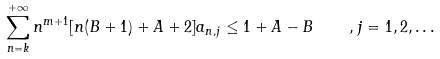<formula> <loc_0><loc_0><loc_500><loc_500>\sum ^ { + \infty } _ { n = k } n ^ { m + 1 } [ n ( B + 1 ) + A + 2 ] a _ { n , j } \leq 1 + A - B \quad , j = 1 , 2 , \dots</formula> 